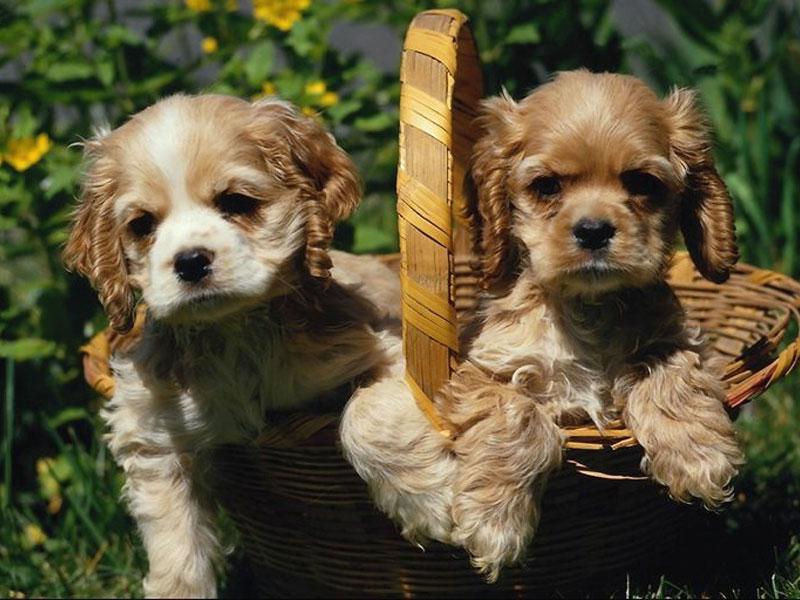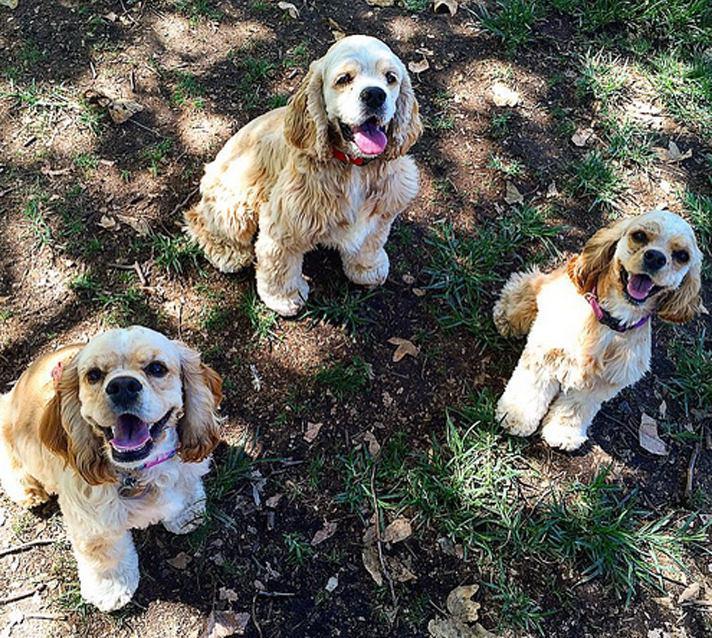The first image is the image on the left, the second image is the image on the right. For the images shown, is this caption "Each image contains at least two cocker spaniels, and at least one image shows cocker spaniels sitting upright and looking upward." true? Answer yes or no. Yes. The first image is the image on the left, the second image is the image on the right. For the images shown, is this caption "The image on the right contains exactly two dogs." true? Answer yes or no. No. 